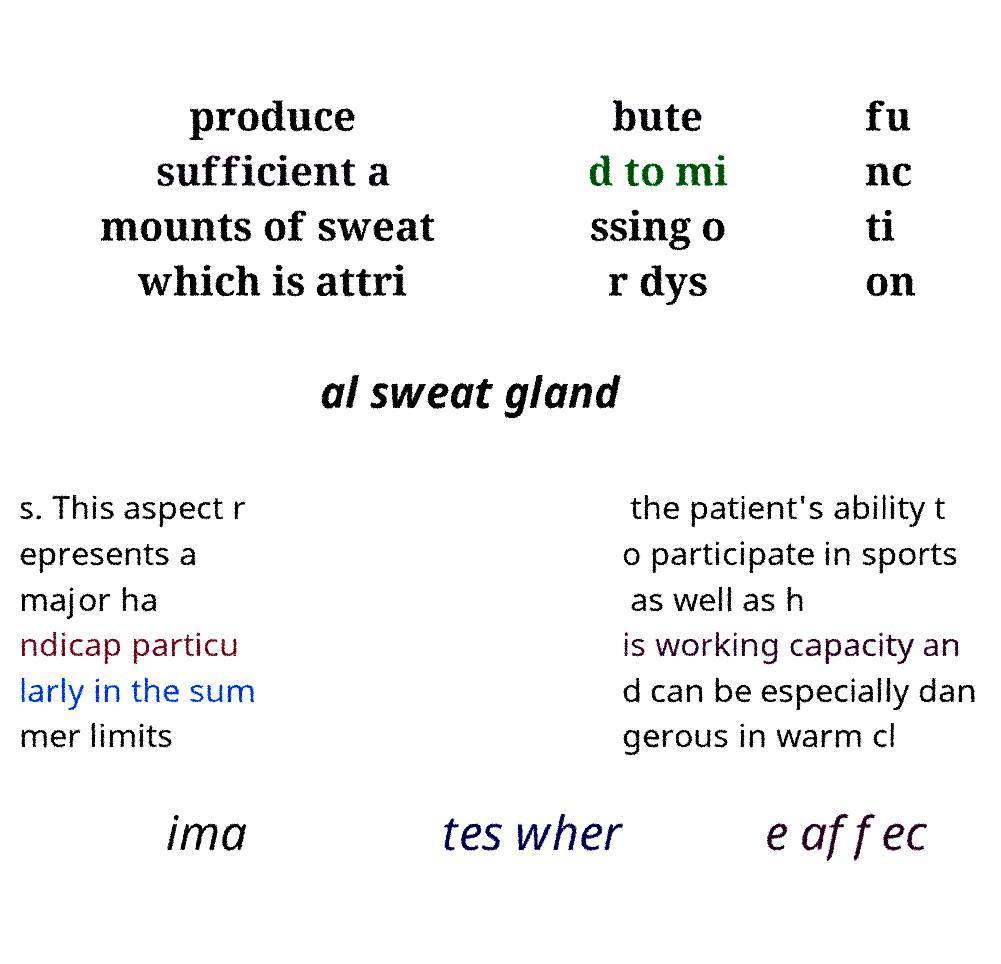Please read and relay the text visible in this image. What does it say? produce sufficient a mounts of sweat which is attri bute d to mi ssing o r dys fu nc ti on al sweat gland s. This aspect r epresents a major ha ndicap particu larly in the sum mer limits the patient's ability t o participate in sports as well as h is working capacity an d can be especially dan gerous in warm cl ima tes wher e affec 